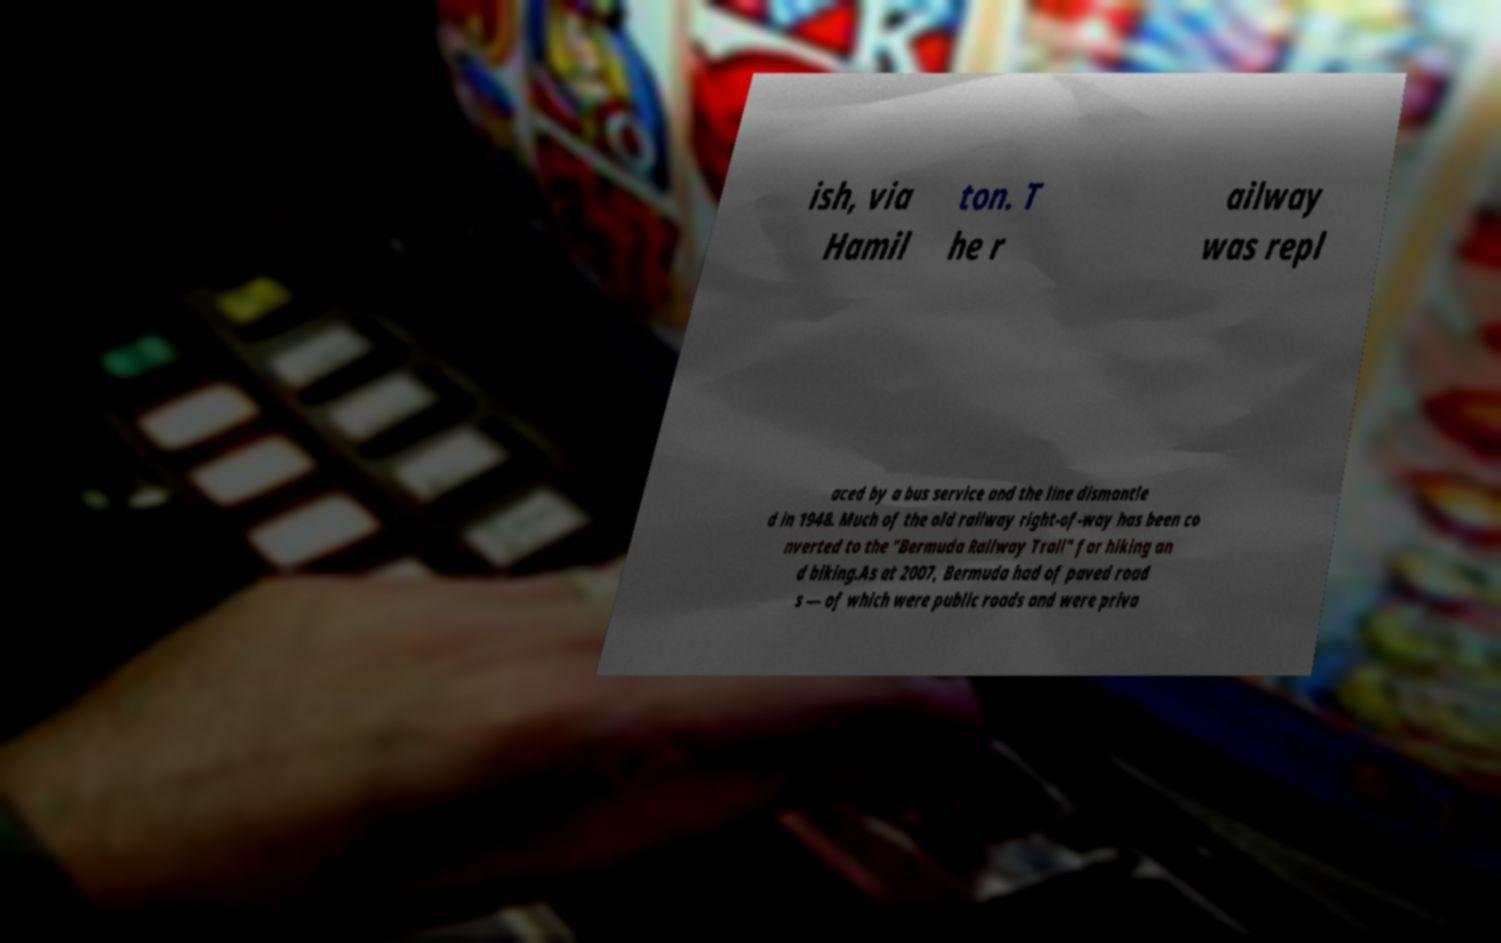What messages or text are displayed in this image? I need them in a readable, typed format. ish, via Hamil ton. T he r ailway was repl aced by a bus service and the line dismantle d in 1948. Much of the old railway right-of-way has been co nverted to the "Bermuda Railway Trail" for hiking an d biking.As at 2007, Bermuda had of paved road s — of which were public roads and were priva 